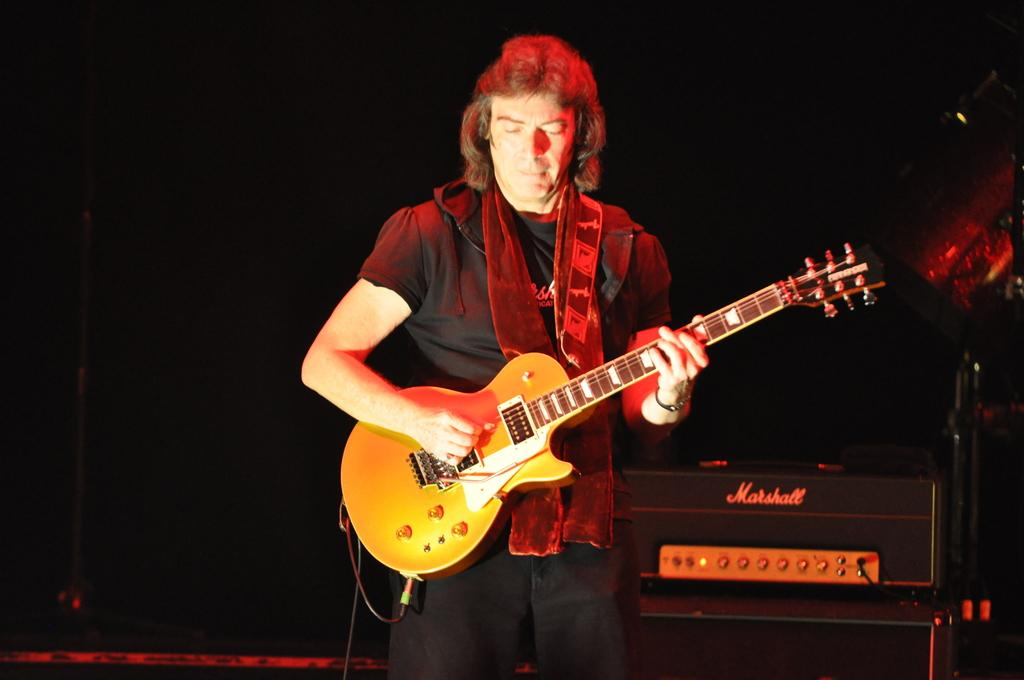What is the main subject of the image? There is a man in the image. What is the man doing in the image? The man is standing and playing a guitar. Can you describe the object behind the man? There is an electronic device behind the man. What type of pets can be seen playing in the hole behind the man? There are no pets or holes present in the image. What kind of beast is lurking behind the man while he plays the guitar? There is no beast present in the image; the man is playing the guitar in front of an electronic device. 